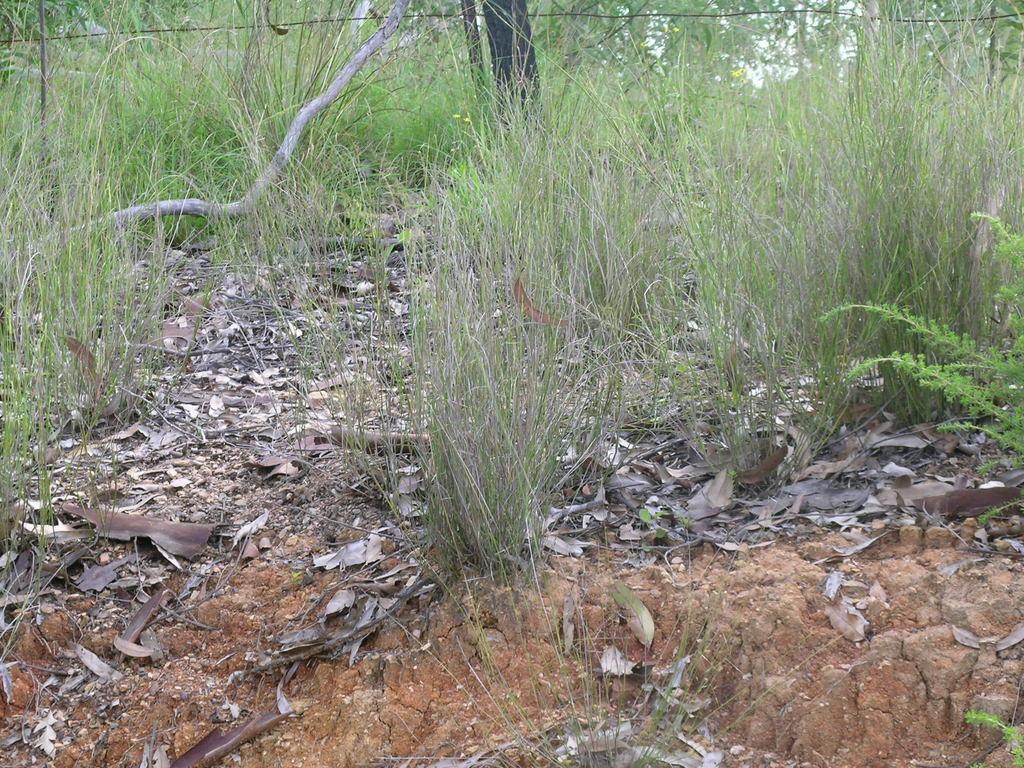Can you describe this image briefly? In this image, we can see some grass and plants. We can also see the ground covered with dried leaves and mud. We can also see some wood and wires. 